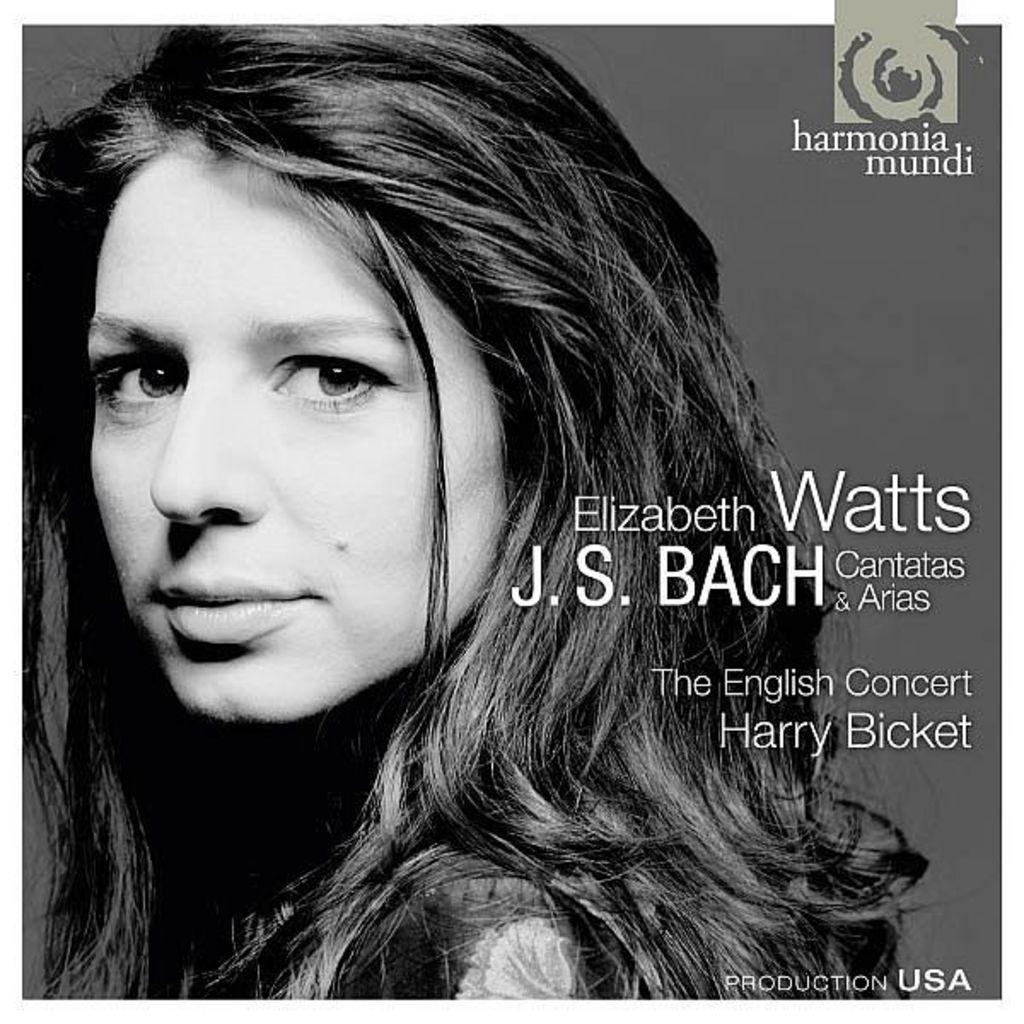How would you summarize this image in a sentence or two? This is a black and white image. On the left side, I can see a woman is looking at the picture. On the right side, I can see some text. 